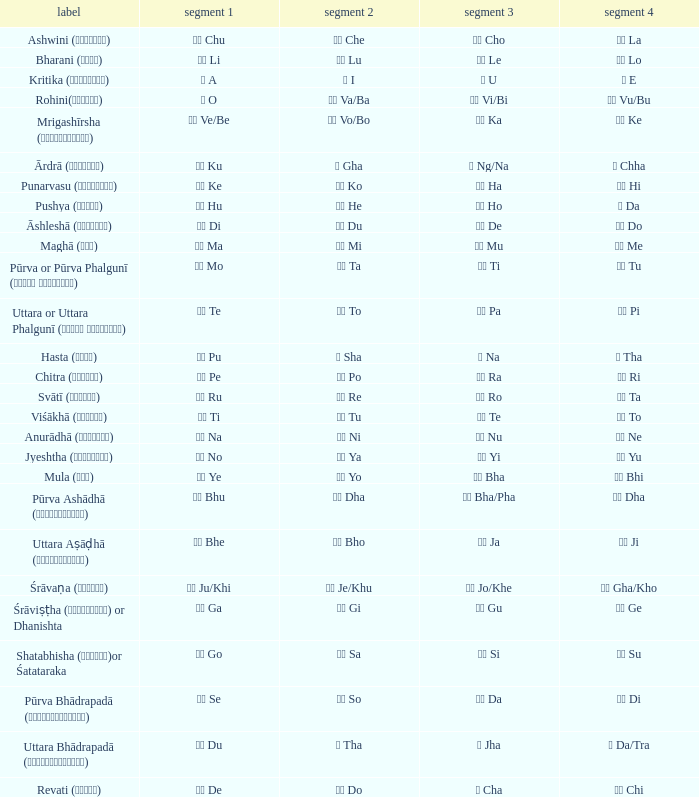What kind of Pada 1 has a Pada 2 of सा sa? गो Go. 